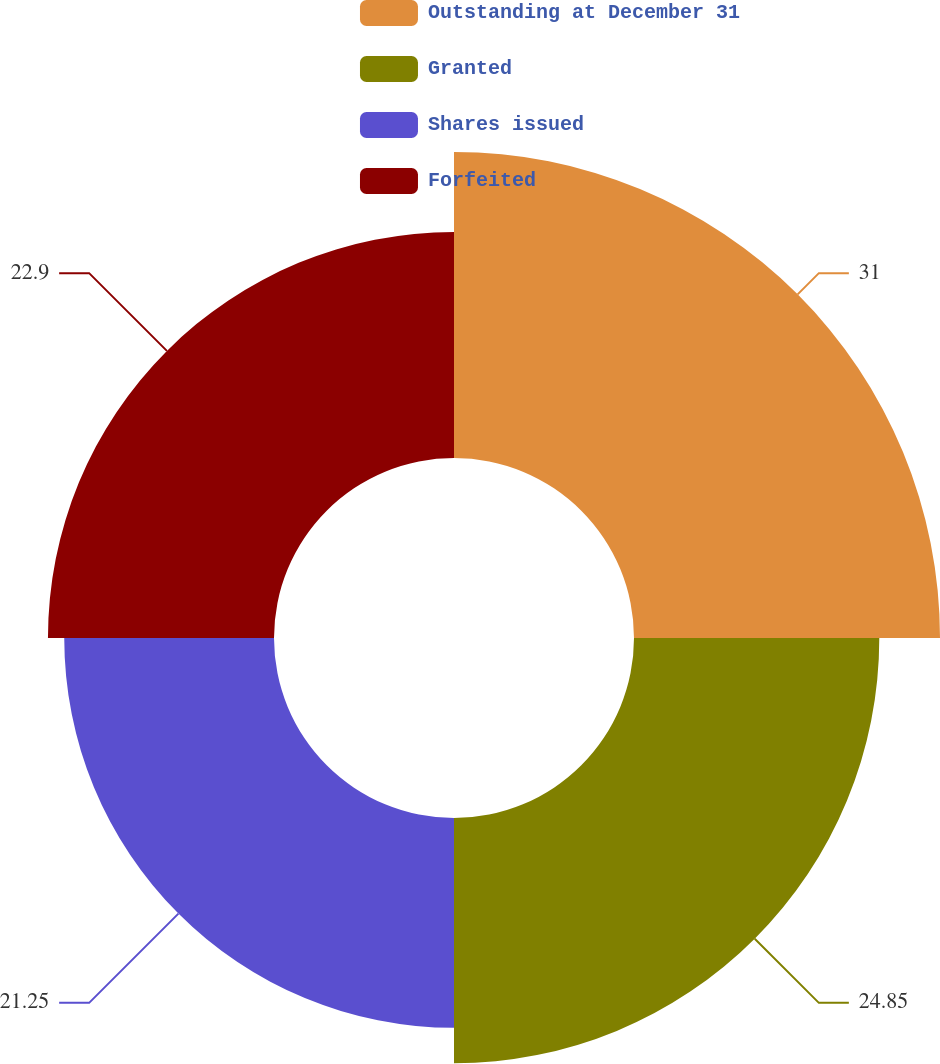Convert chart to OTSL. <chart><loc_0><loc_0><loc_500><loc_500><pie_chart><fcel>Outstanding at December 31<fcel>Granted<fcel>Shares issued<fcel>Forfeited<nl><fcel>31.0%<fcel>24.85%<fcel>21.25%<fcel>22.9%<nl></chart> 